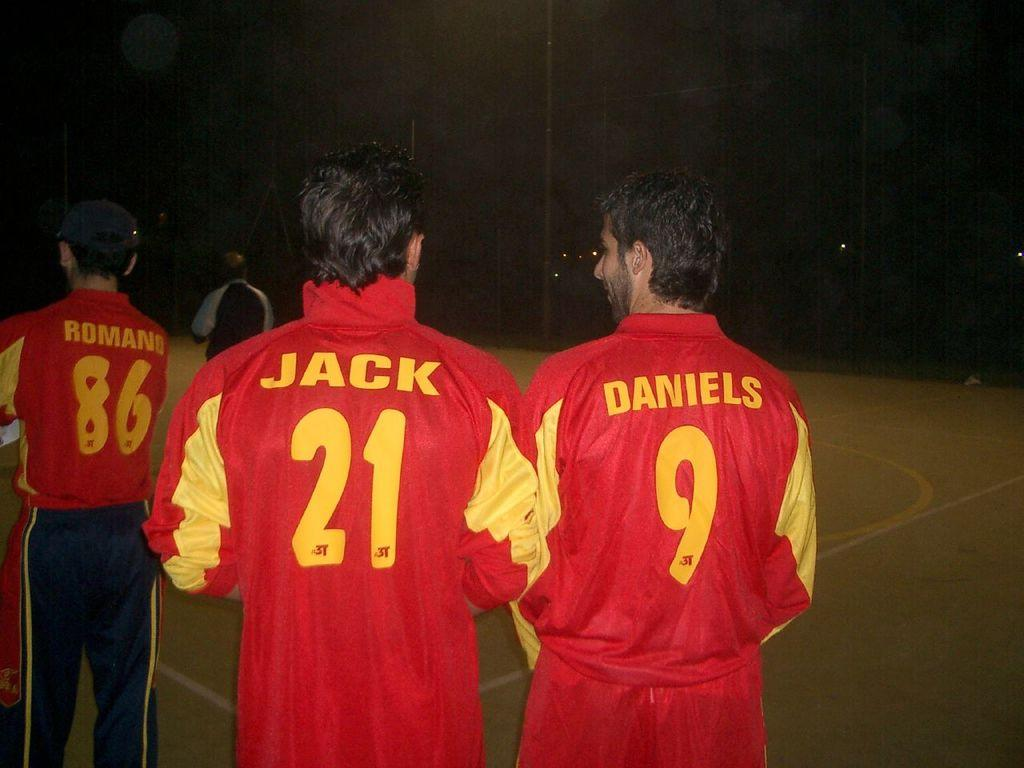<image>
Present a compact description of the photo's key features. Three soccer players standing near each other with the text "Romano", "Jack", and "Daniels" on the back of their uniforms. 